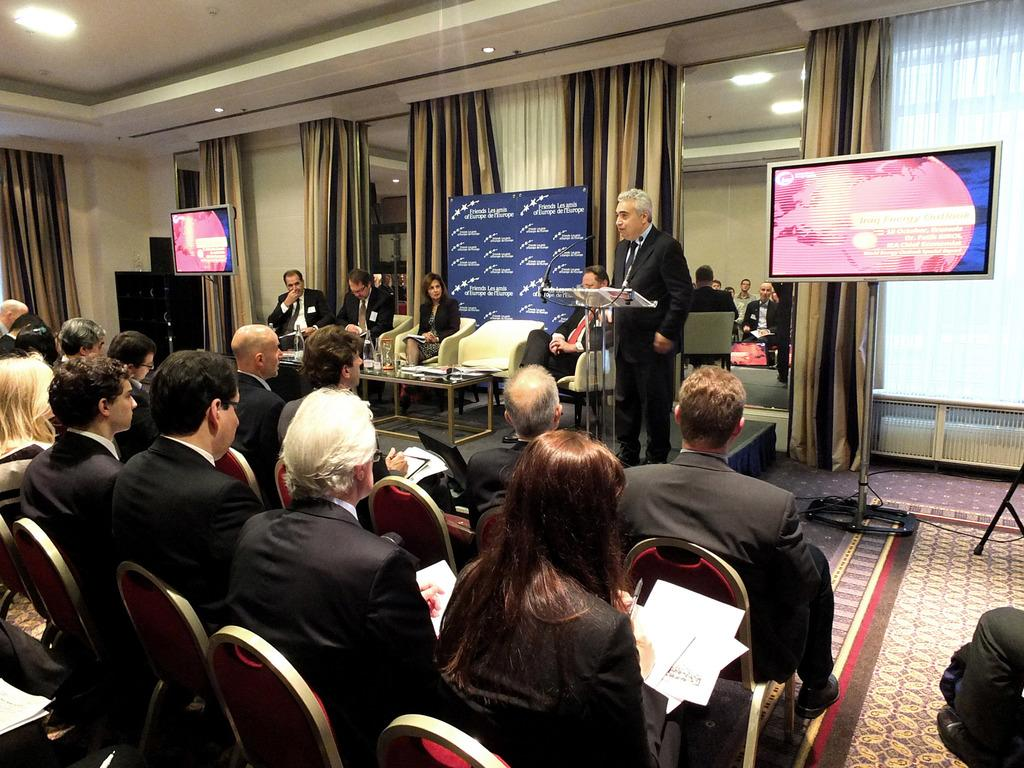What are the people on the left side of the image doing? The people on the left side of the image are sitting on chairs. What is the man near the microphone doing? The man is standing near a microphone. What can be seen at the top of the image? There are lights visible at the top of the image. What type of reward is being handed out to the people in the image? There is no reward being handed out in the image; it only shows people sitting on chairs and a man standing near a microphone. Can you see any fog in the image? There is no fog present in the image. 